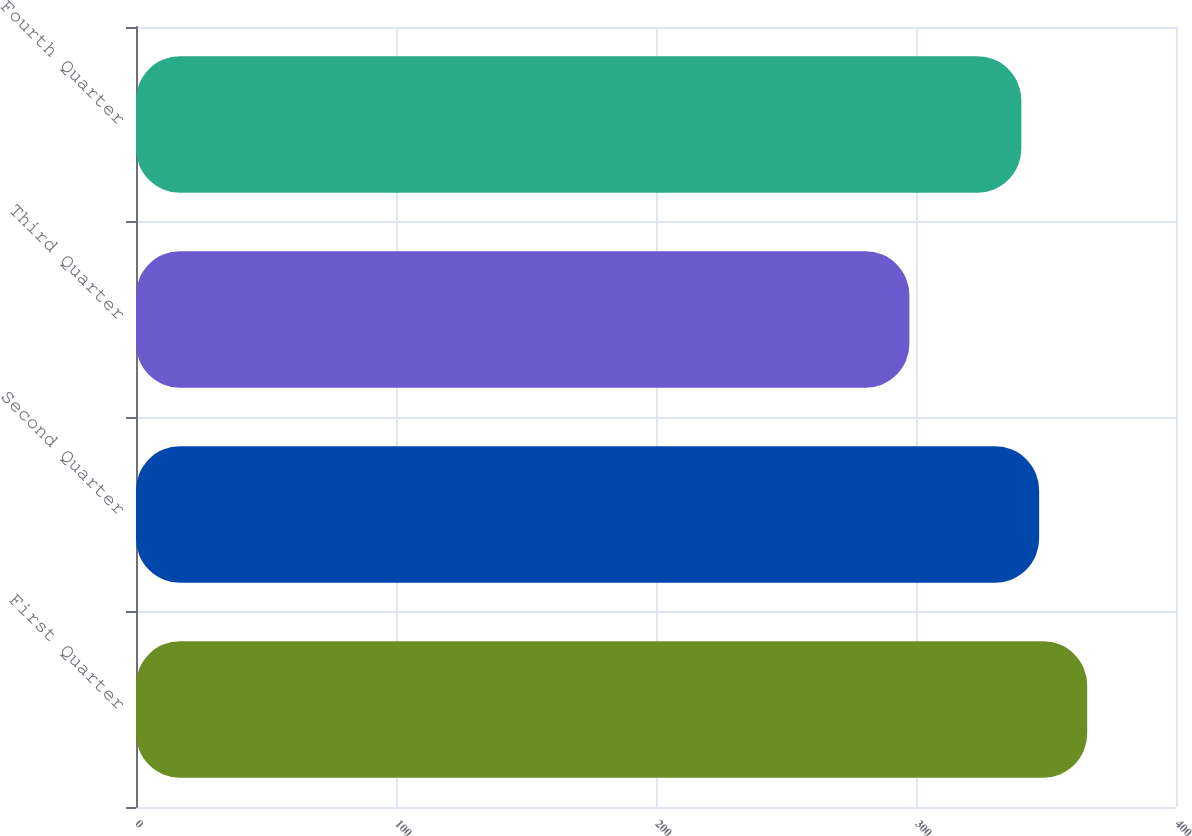<chart> <loc_0><loc_0><loc_500><loc_500><bar_chart><fcel>First Quarter<fcel>Second Quarter<fcel>Third Quarter<fcel>Fourth Quarter<nl><fcel>365.84<fcel>347.36<fcel>297.47<fcel>340.52<nl></chart> 